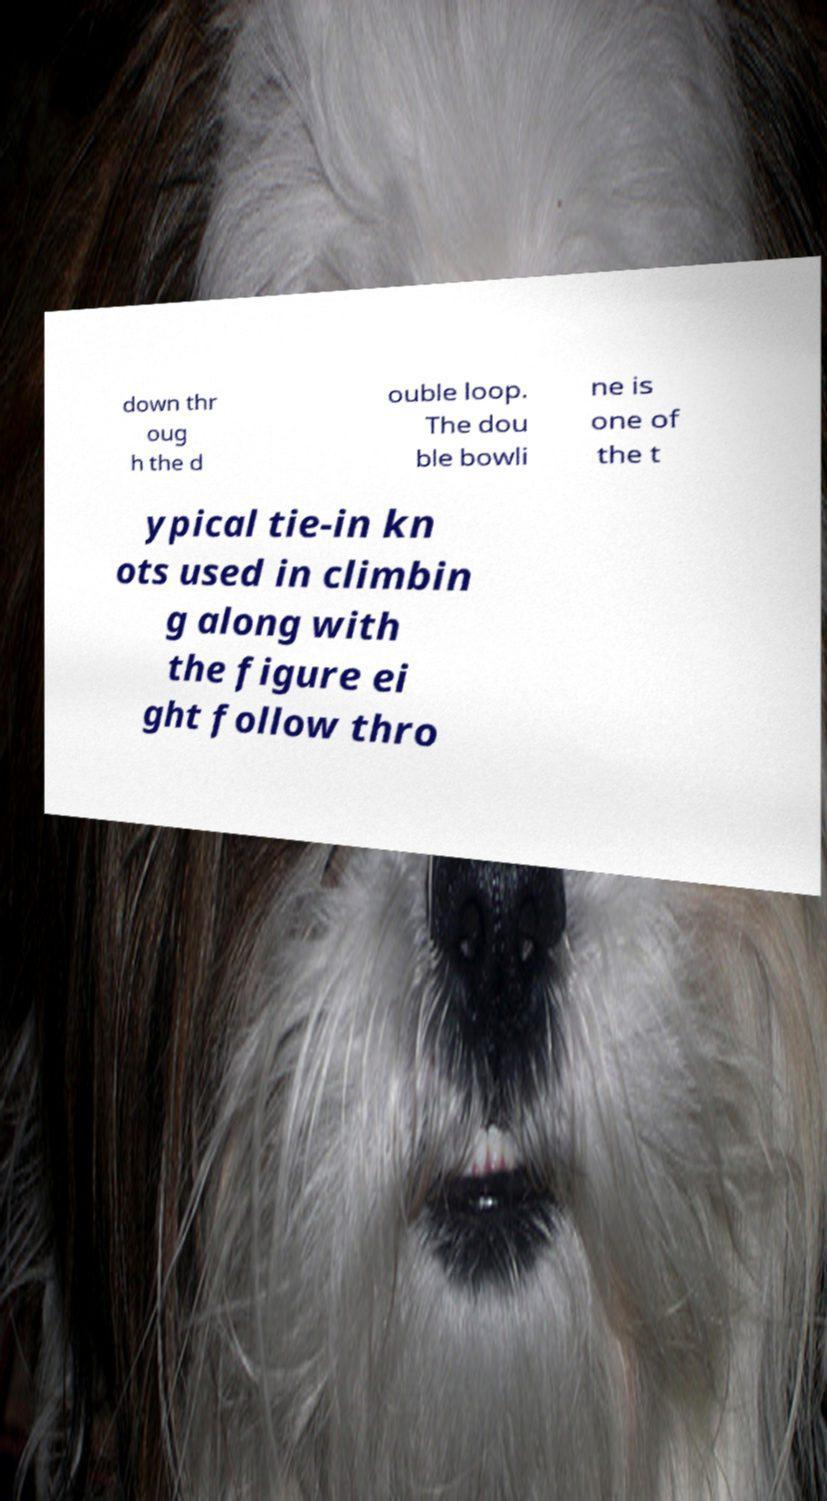I need the written content from this picture converted into text. Can you do that? down thr oug h the d ouble loop. The dou ble bowli ne is one of the t ypical tie-in kn ots used in climbin g along with the figure ei ght follow thro 